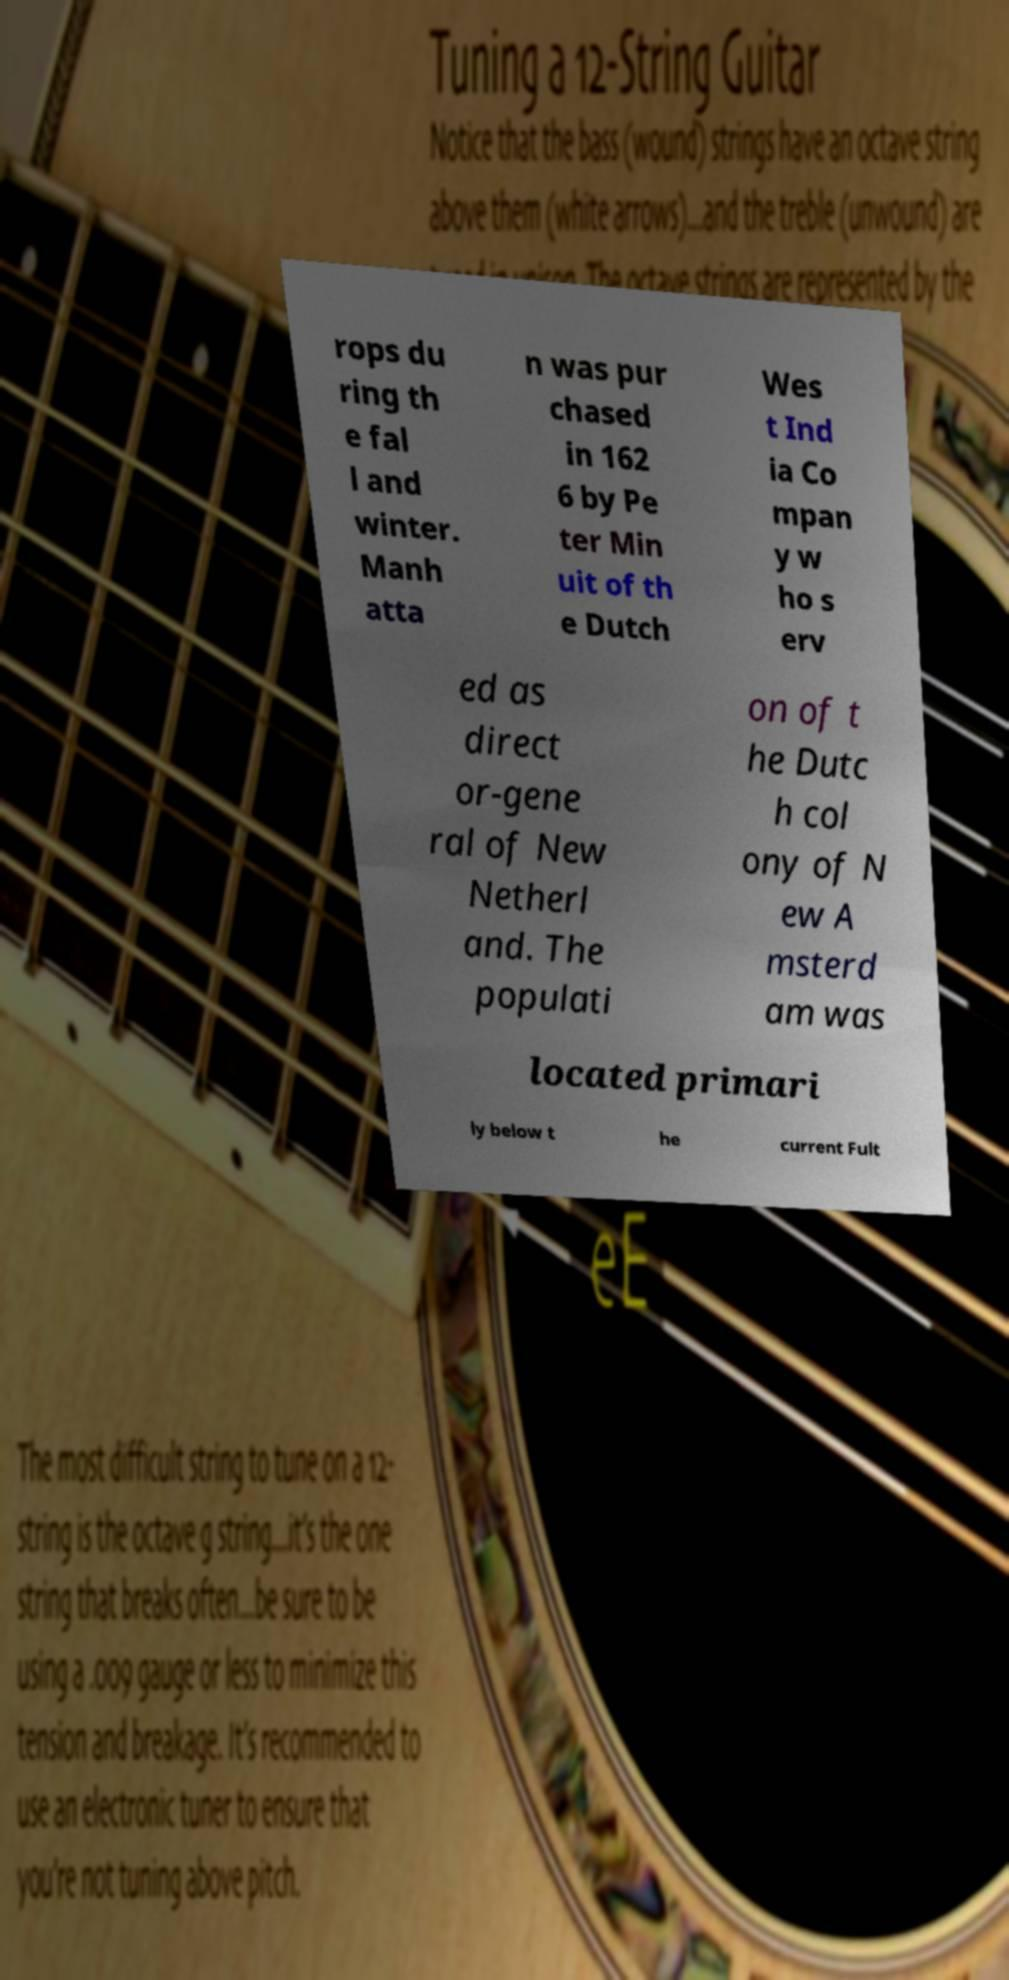Can you read and provide the text displayed in the image?This photo seems to have some interesting text. Can you extract and type it out for me? rops du ring th e fal l and winter. Manh atta n was pur chased in 162 6 by Pe ter Min uit of th e Dutch Wes t Ind ia Co mpan y w ho s erv ed as direct or-gene ral of New Netherl and. The populati on of t he Dutc h col ony of N ew A msterd am was located primari ly below t he current Fult 